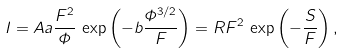Convert formula to latex. <formula><loc_0><loc_0><loc_500><loc_500>I = A a \frac { F ^ { 2 } } { \varPhi } \, \exp \left ( - b \frac { \varPhi ^ { 3 / 2 } } { F } \right ) = R F ^ { 2 } \, \exp \left ( - \frac { S } { F } \right ) ,</formula> 